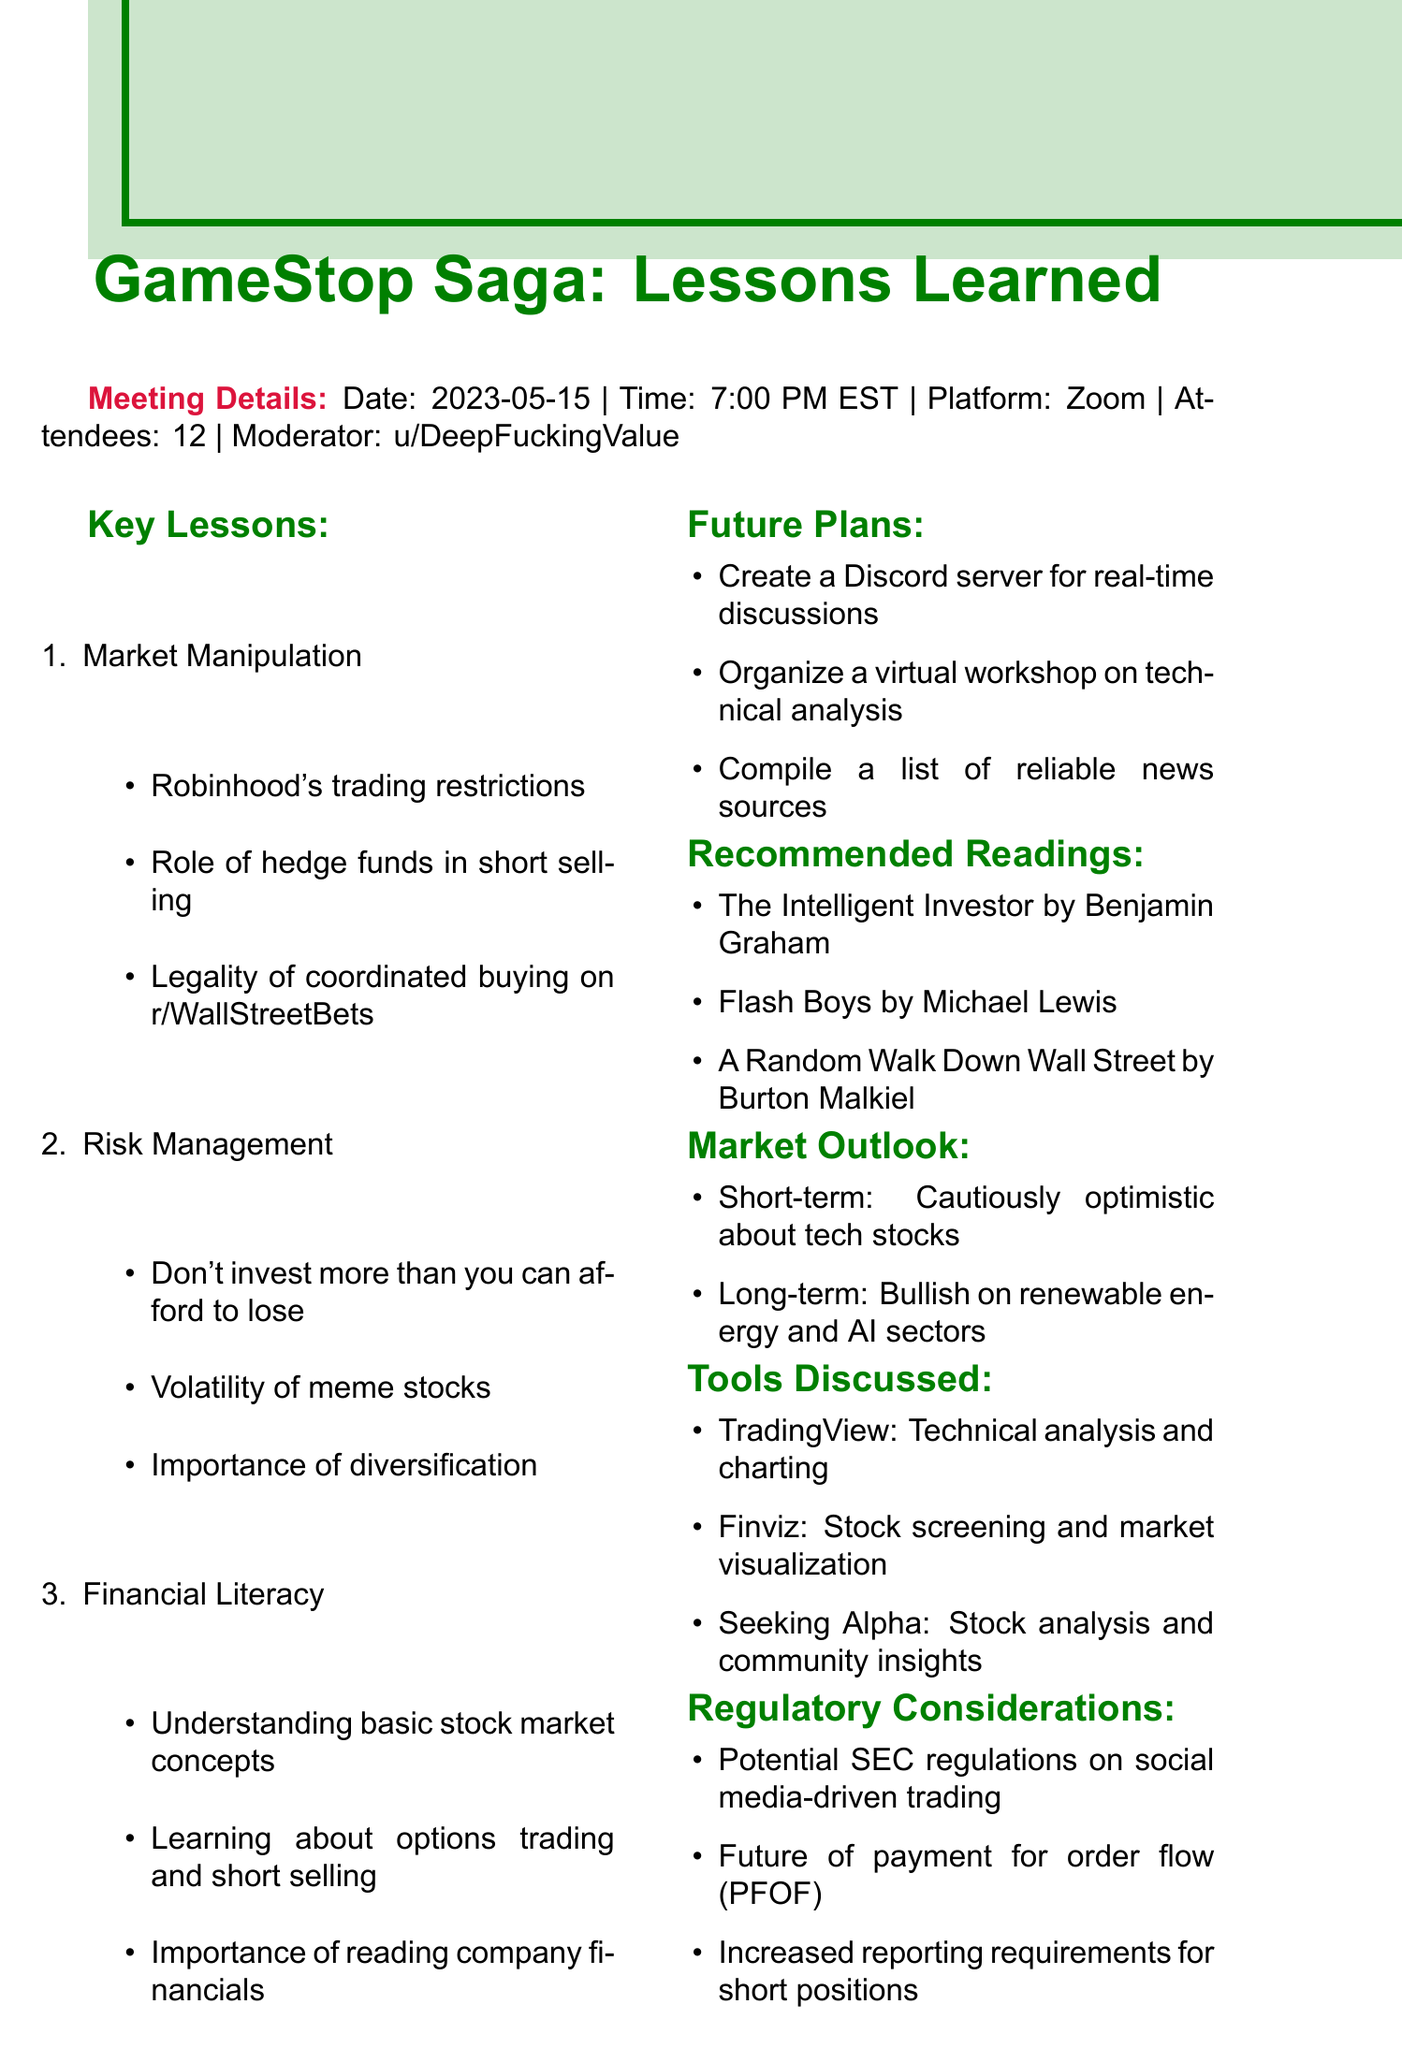what date was the meeting held? The date of the meeting is listed in the meeting details section.
Answer: 2023-05-15 who was the moderator of the meeting? The moderator's name is specified in the meeting details section.
Answer: u/DeepFuckingValue how many attendees were present at the meeting? The number of attendees is provided in the meeting details.
Answer: 12 what is one of the topics discussed under key lessons? The topics under key lessons are enumerated in the document.
Answer: Market Manipulation which book is recommended for reading on financial literacy? The recommended readings section lists specific titles and authors.
Answer: The Intelligent Investor what tool is suggested for technical analysis and charting? The tools discussed section specifies different tools and their purposes.
Answer: TradingView what is the short-term market outlook? The market outlook section outlines the perception of market conditions for the short term.
Answer: Cautiously optimistic about tech stocks what is one of the future plans mentioned in the meeting? The future plans section provides various initiatives discussed during the meeting.
Answer: Create a Discord server for real-time discussions what regulatory consideration was discussed during the meeting? The regulatory considerations section highlights important topics addressed in the discussion.
Answer: Potential SEC regulations on social media-driven trading 